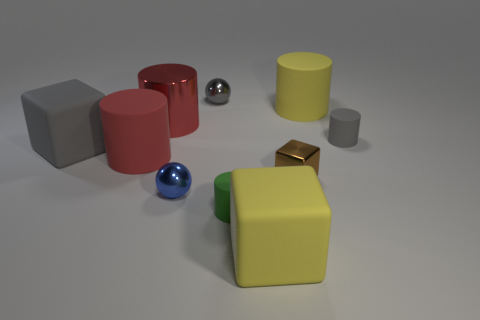The block that is the same size as the gray metal sphere is what color?
Provide a succinct answer. Brown. Is there a matte cylinder that has the same color as the large shiny object?
Ensure brevity in your answer.  Yes. Are there fewer big yellow rubber cylinders that are behind the green object than cylinders to the left of the gray shiny sphere?
Your answer should be compact. Yes. There is a gray object that is on the left side of the yellow cylinder and right of the blue shiny thing; what is its material?
Offer a very short reply. Metal. There is a blue shiny thing; is its shape the same as the small shiny thing that is behind the large red rubber cylinder?
Ensure brevity in your answer.  Yes. What number of other objects are the same size as the brown metal block?
Make the answer very short. 4. Is the number of purple matte spheres greater than the number of small gray balls?
Give a very brief answer. No. What number of tiny things are right of the blue metal thing and left of the large yellow cube?
Make the answer very short. 2. The tiny object that is behind the metal cylinder to the right of the big block that is behind the tiny green object is what shape?
Keep it short and to the point. Sphere. How many balls are either red objects or red metallic things?
Keep it short and to the point. 0. 